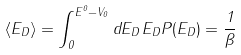Convert formula to latex. <formula><loc_0><loc_0><loc_500><loc_500>\langle E _ { D } \rangle = \int _ { 0 } ^ { E ^ { 0 } - V _ { 0 } } d E _ { D } \, E _ { D } P ( E _ { D } ) = \frac { 1 } { \beta }</formula> 